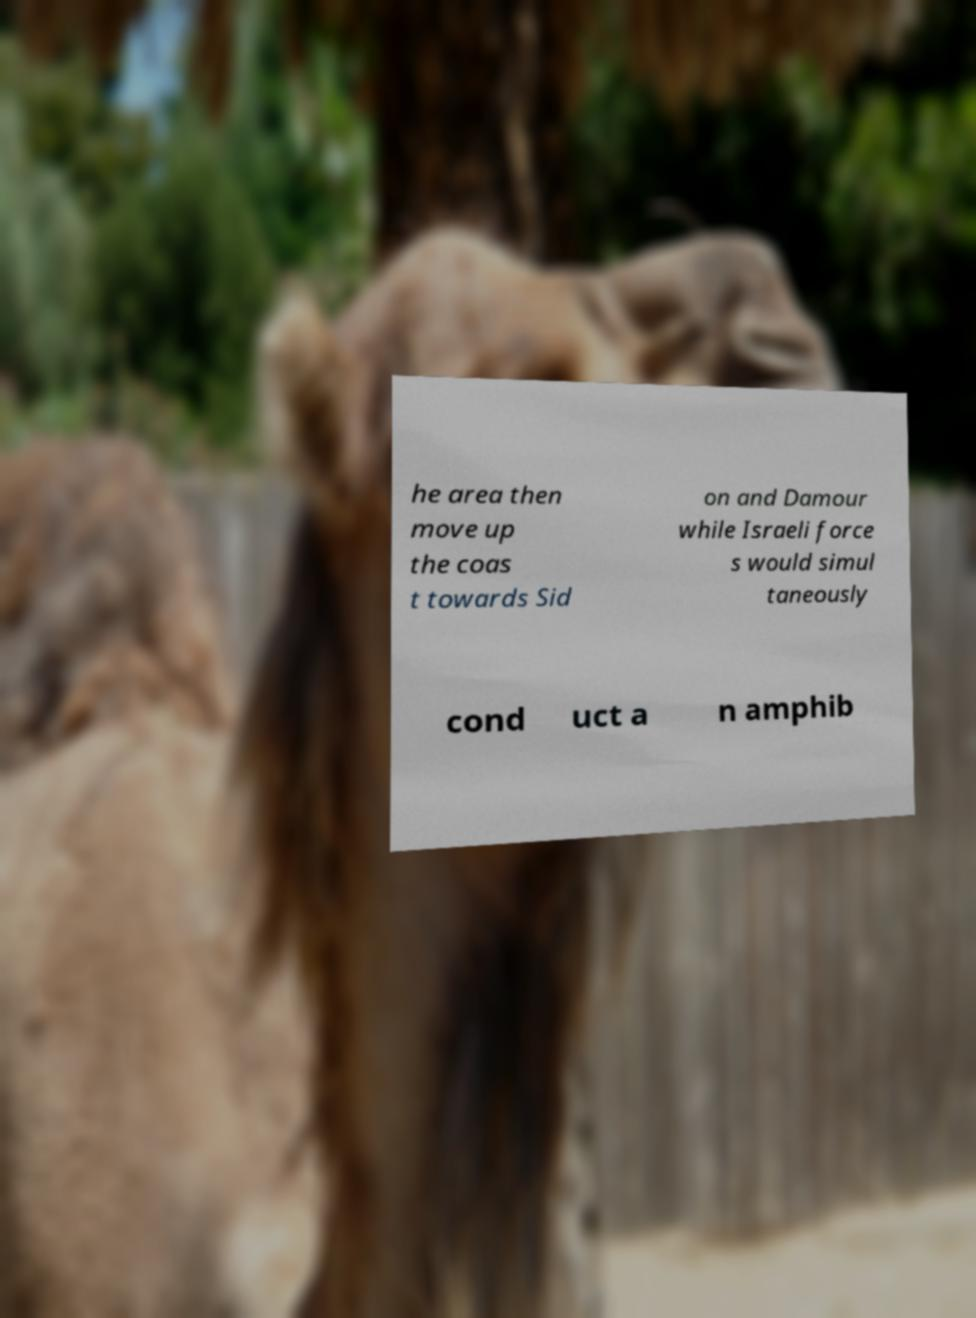Can you accurately transcribe the text from the provided image for me? he area then move up the coas t towards Sid on and Damour while Israeli force s would simul taneously cond uct a n amphib 